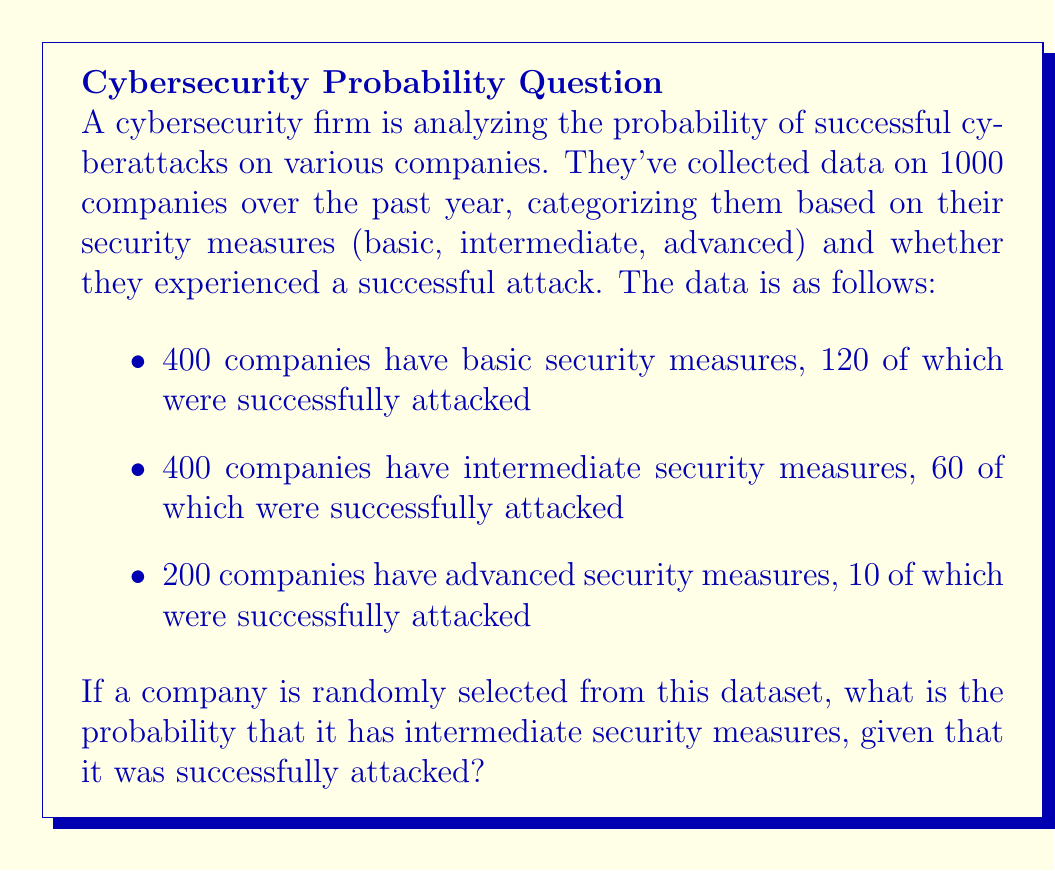Help me with this question. To solve this problem, we'll use Bayes' Theorem, which is particularly useful for calculating conditional probabilities. Let's define our events:

A: The company has intermediate security measures
B: The company was successfully attacked

We want to find P(A|B), the probability of A given B.

Bayes' Theorem states:

$$ P(A|B) = \frac{P(B|A) \cdot P(A)}{P(B)} $$

Let's calculate each component:

1. P(A) - Probability of intermediate security measures:
   $P(A) = \frac{400}{1000} = 0.4$

2. P(B|A) - Probability of successful attack given intermediate security:
   $P(B|A) = \frac{60}{400} = 0.15$

3. P(B) - Overall probability of a successful attack:
   $P(B) = \frac{120 + 60 + 10}{1000} = \frac{190}{1000} = 0.19$

Now, let's plug these values into Bayes' Theorem:

$$ P(A|B) = \frac{0.15 \cdot 0.4}{0.19} = \frac{0.06}{0.19} \approx 0.3158 $$

Therefore, the probability that a randomly selected company has intermediate security measures, given that it was successfully attacked, is approximately 0.3158 or 31.58%.
Answer: 0.3158 or 31.58% 